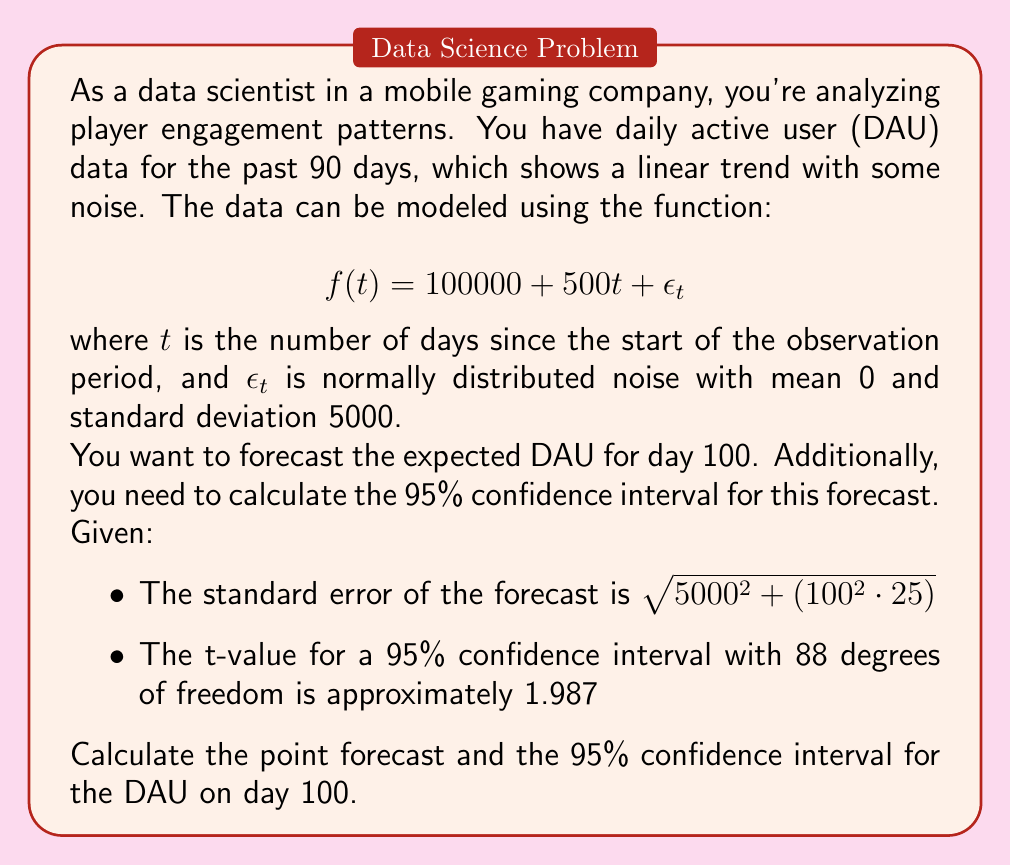Teach me how to tackle this problem. Let's approach this step-by-step:

1) First, we need to calculate the point forecast for day 100. We can do this by simply plugging t = 100 into our function:

   $$f(100) = 100000 + 500(100) = 100000 + 50000 = 150000$$

2) Now, we need to calculate the confidence interval. The general form of a confidence interval is:

   $$\text{Point Forecast} \pm (t\text{-value} \cdot \text{Standard Error})$$

3) We're given the standard error of the forecast:

   $$\sqrt{5000^2 + (100^2 \cdot 25)} = \sqrt{25000000 + 250000} = \sqrt{25250000} = 5025$$

4) We're also given the t-value for a 95% confidence interval: 1.987

5) Now we can calculate the margin of error:

   $$1.987 \cdot 5025 \approx 9984.675$$

6) Finally, we can calculate the confidence interval:

   Lower bound: $150000 - 9984.675 \approx 140015$
   Upper bound: $150000 + 9984.675 \approx 159985$

Therefore, we can say with 95% confidence that the true DAU for day 100 will fall between approximately 140,015 and 159,985.
Answer: Point forecast for DAU on day 100: 150,000
95% Confidence Interval: (140,015, 159,985) 